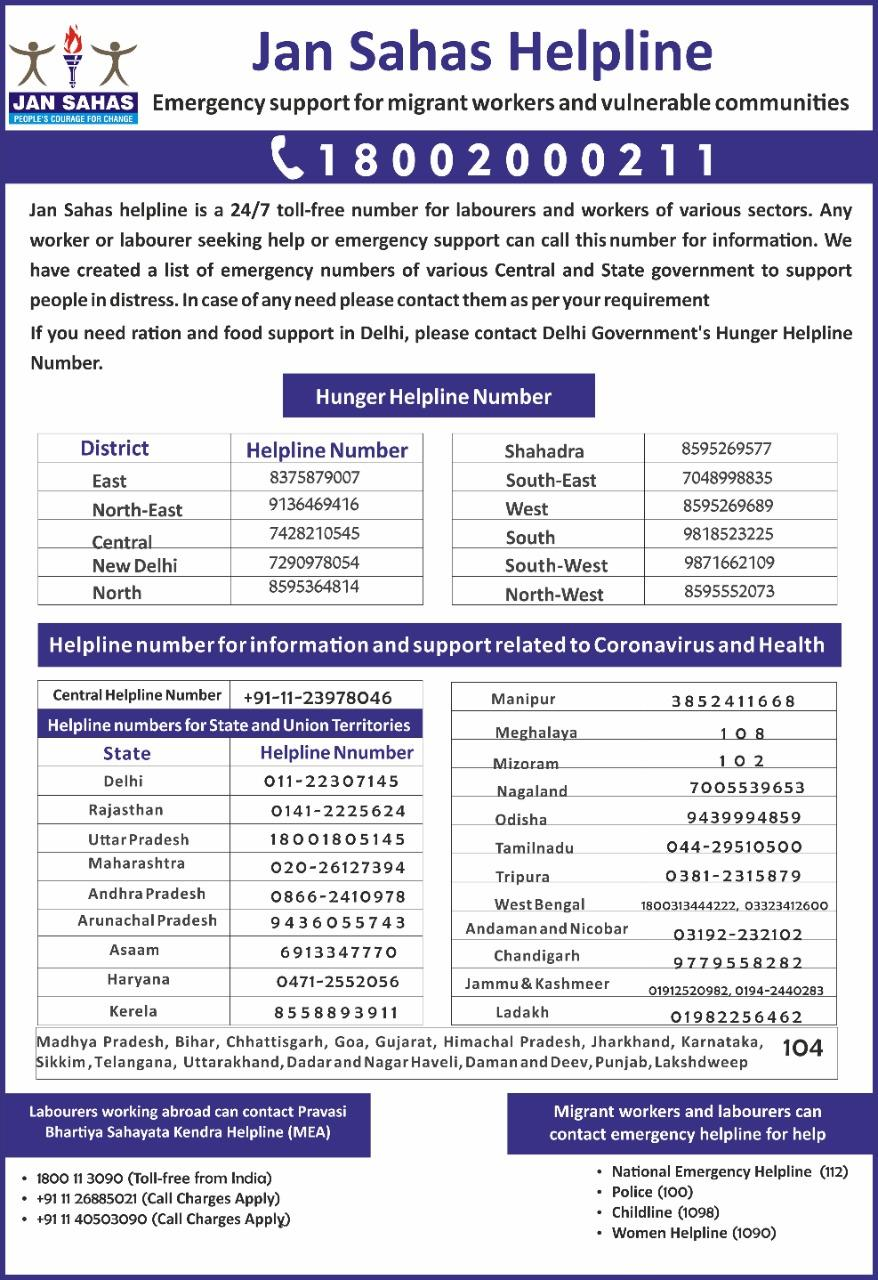Outline some significant characteristics in this image. In Bihar and Punjab, a specific number can be called for information. This number is 104. In total, 44 phone numbers are provided. 